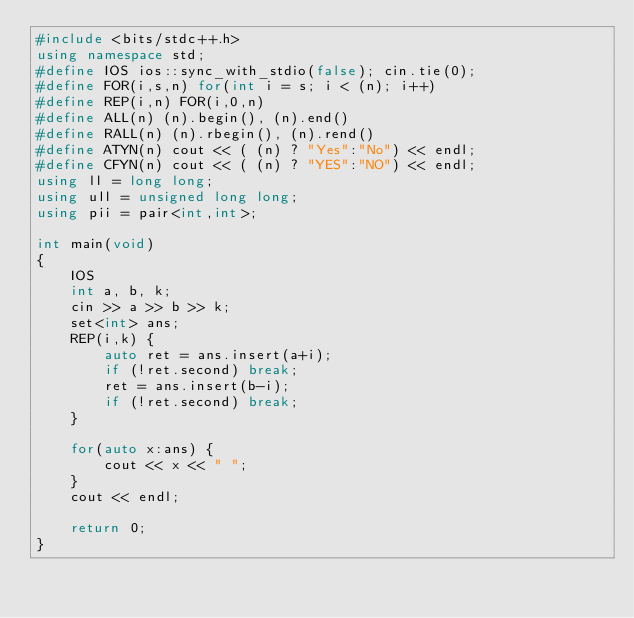<code> <loc_0><loc_0><loc_500><loc_500><_C++_>#include <bits/stdc++.h>
using namespace std;
#define IOS ios::sync_with_stdio(false); cin.tie(0);
#define FOR(i,s,n) for(int i = s; i < (n); i++)
#define REP(i,n) FOR(i,0,n)
#define ALL(n) (n).begin(), (n).end()
#define RALL(n) (n).rbegin(), (n).rend()
#define ATYN(n) cout << ( (n) ? "Yes":"No") << endl;
#define CFYN(n) cout << ( (n) ? "YES":"NO") << endl;
using ll = long long;
using ull = unsigned long long;
using pii = pair<int,int>;

int main(void)
{
    IOS
    int a, b, k;
    cin >> a >> b >> k;
    set<int> ans;
    REP(i,k) {
        auto ret = ans.insert(a+i);
        if (!ret.second) break;
        ret = ans.insert(b-i);
        if (!ret.second) break;
    }

    for(auto x:ans) {
        cout << x << " ";
    }
    cout << endl;

    return 0;
}</code> 